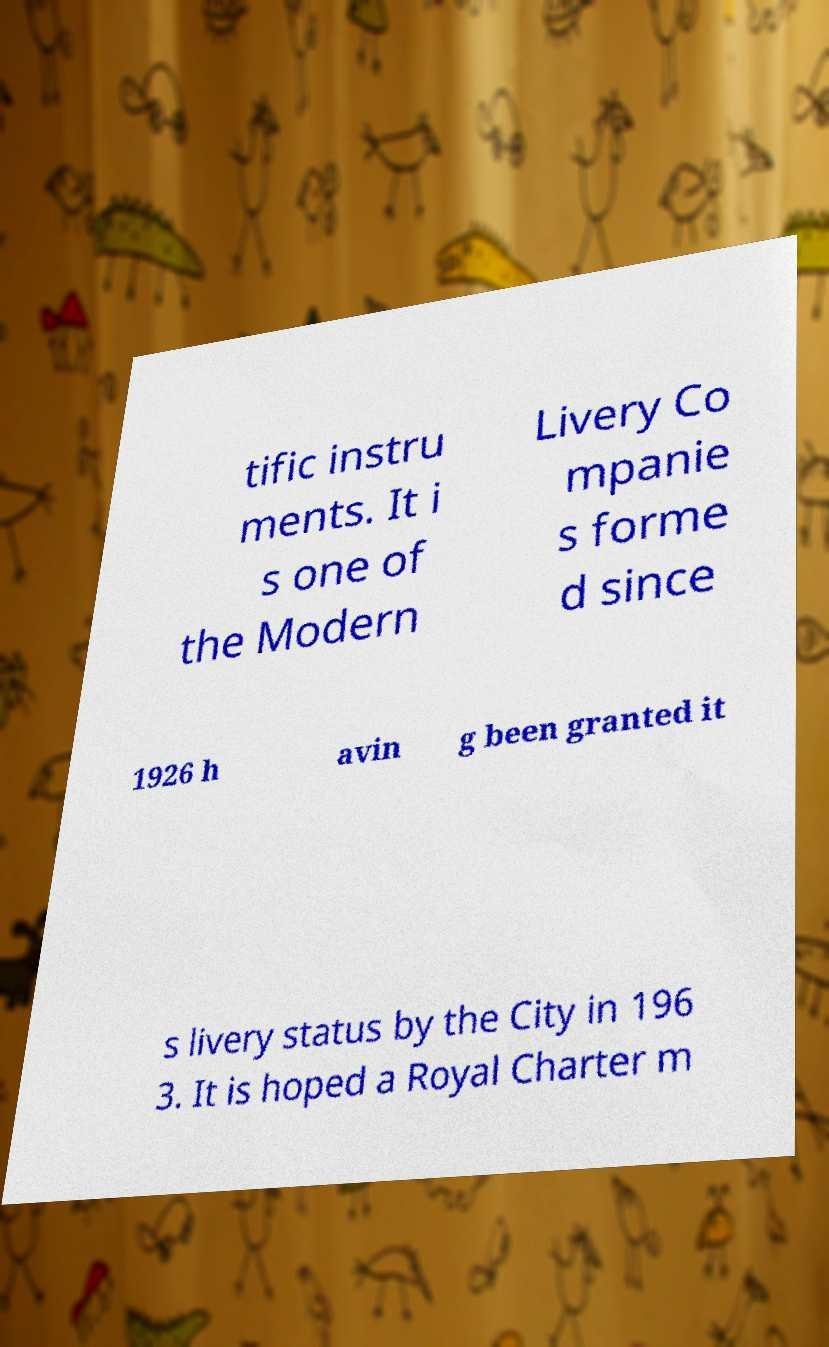Can you accurately transcribe the text from the provided image for me? tific instru ments. It i s one of the Modern Livery Co mpanie s forme d since 1926 h avin g been granted it s livery status by the City in 196 3. It is hoped a Royal Charter m 